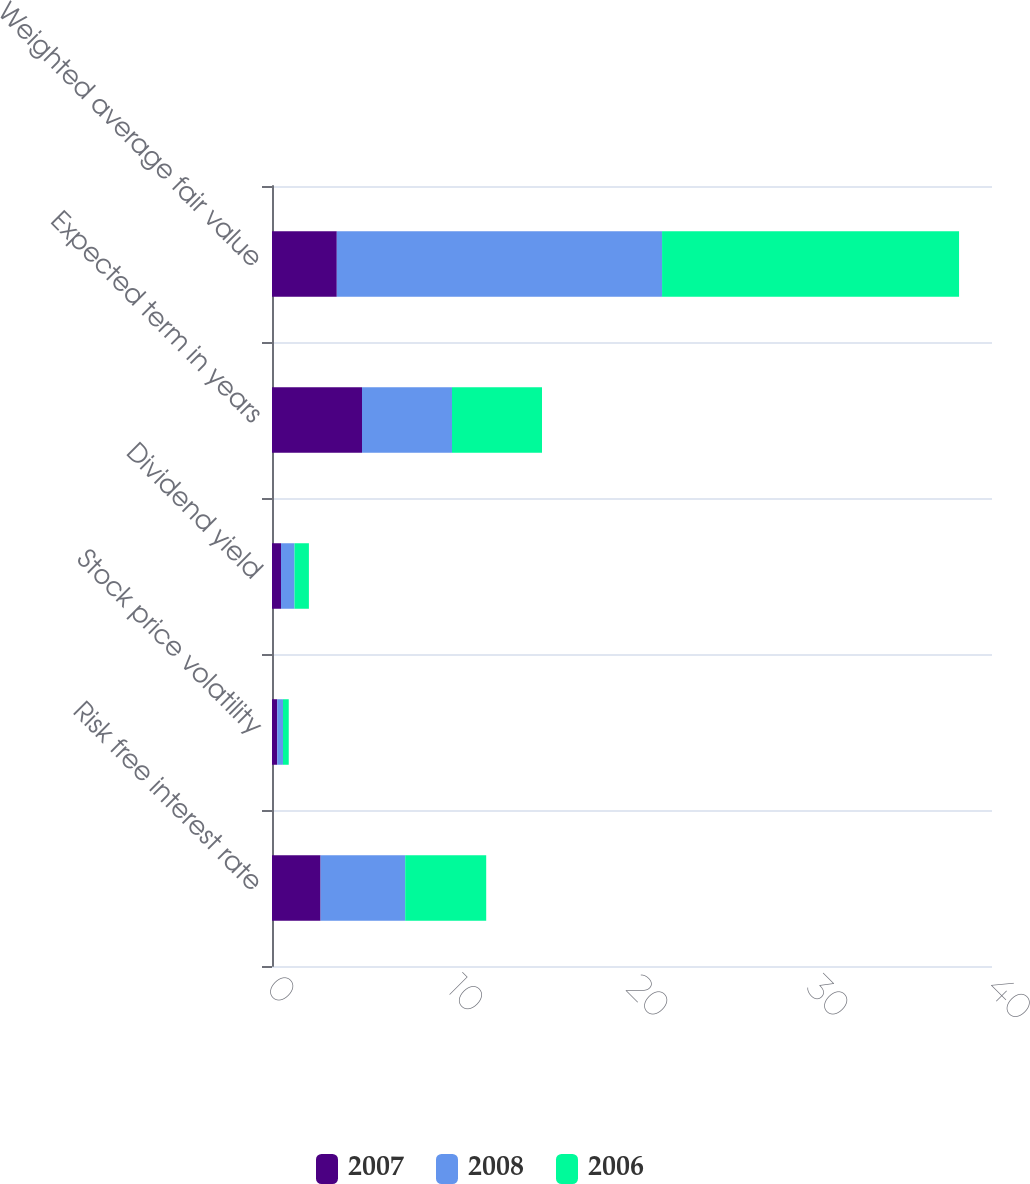<chart> <loc_0><loc_0><loc_500><loc_500><stacked_bar_chart><ecel><fcel>Risk free interest rate<fcel>Stock price volatility<fcel>Dividend yield<fcel>Expected term in years<fcel>Weighted average fair value<nl><fcel>2007<fcel>2.7<fcel>0.29<fcel>0.5<fcel>5<fcel>3.6<nl><fcel>2008<fcel>4.7<fcel>0.32<fcel>0.75<fcel>5<fcel>18.07<nl><fcel>2006<fcel>4.5<fcel>0.32<fcel>0.8<fcel>5<fcel>16.5<nl></chart> 